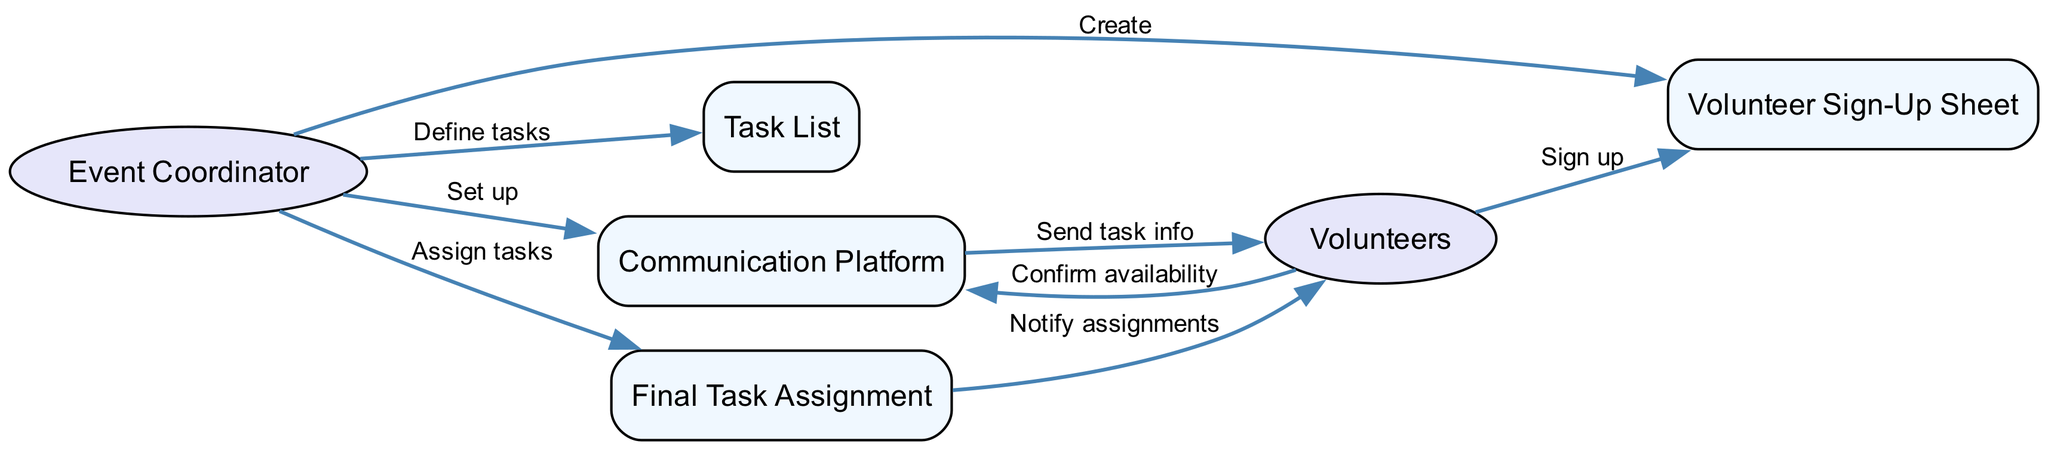What are the three main actors in the diagram? The main actors identified in the diagram are the Event Coordinator and the Volunteers. Each of these actors performs distinct roles related to the coordination of the outreach event.
Answer: Event Coordinator, Volunteers How many objects are present in the diagram? The diagram contains four objects: Volunteer Sign-Up Sheet, Task List, Communication Platform, and Final Task Assignment. Each object represents a component involved in the volunteer coordination process.
Answer: Four What action does the Event Coordinator take towards the Task List? The Event Coordinator defines tasks in relation to the Task List. This action indicates that the Event Coordinator is responsible for specifying what needs to be done for the event.
Answer: Define tasks What is the first interaction in the sequence? The first interaction occurs between the Event Coordinator and the Volunteer Sign-Up Sheet, where the Event Coordinator creates the sign-up sheet to facilitate volunteer participation.
Answer: Create How many total edges are present in the diagram? Counting all the connections or interactions (edges) between actors and objects yields a total of eight edges, illustrating the flow of actions in the sequence.
Answer: Eight Which interaction confirms availability from the Volunteers? The interaction that confirms availability is initiated by the Volunteers towards the Communication Platform, indicating that Volunteers respond to the information sent by the Event Coordinator.
Answer: Confirm availability What does the Communication Platform do after setup? After setup by the Event Coordinator, the Communication Platform sends task info to the Volunteers. This step is crucial for ensuring that the Volunteers are informed about their responsibilities for the event.
Answer: Send task info Which object does the Event Coordinator use to notify Volunteer assignments? The Event Coordinator uses the Final Task Assignment object to notify the Volunteers of their assigned tasks, ensuring that all participants are aware of their specific roles.
Answer: Notify assignments 